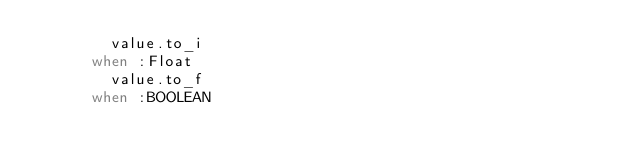Convert code to text. <code><loc_0><loc_0><loc_500><loc_500><_Ruby_>        value.to_i
      when :Float
        value.to_f
      when :BOOLEAN</code> 